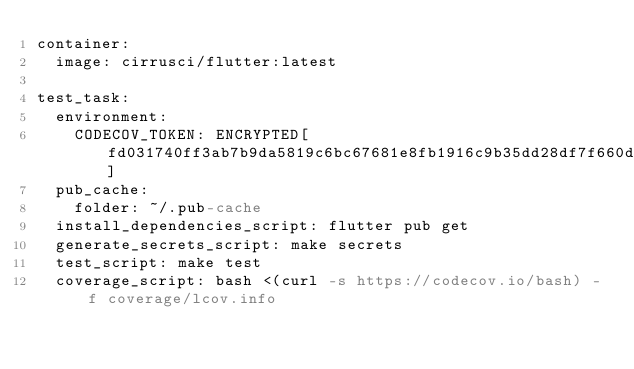<code> <loc_0><loc_0><loc_500><loc_500><_YAML_>container:
  image: cirrusci/flutter:latest

test_task:
  environment:
    CODECOV_TOKEN: ENCRYPTED[fd031740ff3ab7b9da5819c6bc67681e8fb1916c9b35dd28df7f660dc0d84752f2caceefaf17f6598b7126772f9943cb]
  pub_cache:
    folder: ~/.pub-cache
  install_dependencies_script: flutter pub get
  generate_secrets_script: make secrets
  test_script: make test
  coverage_script: bash <(curl -s https://codecov.io/bash) -f coverage/lcov.info</code> 